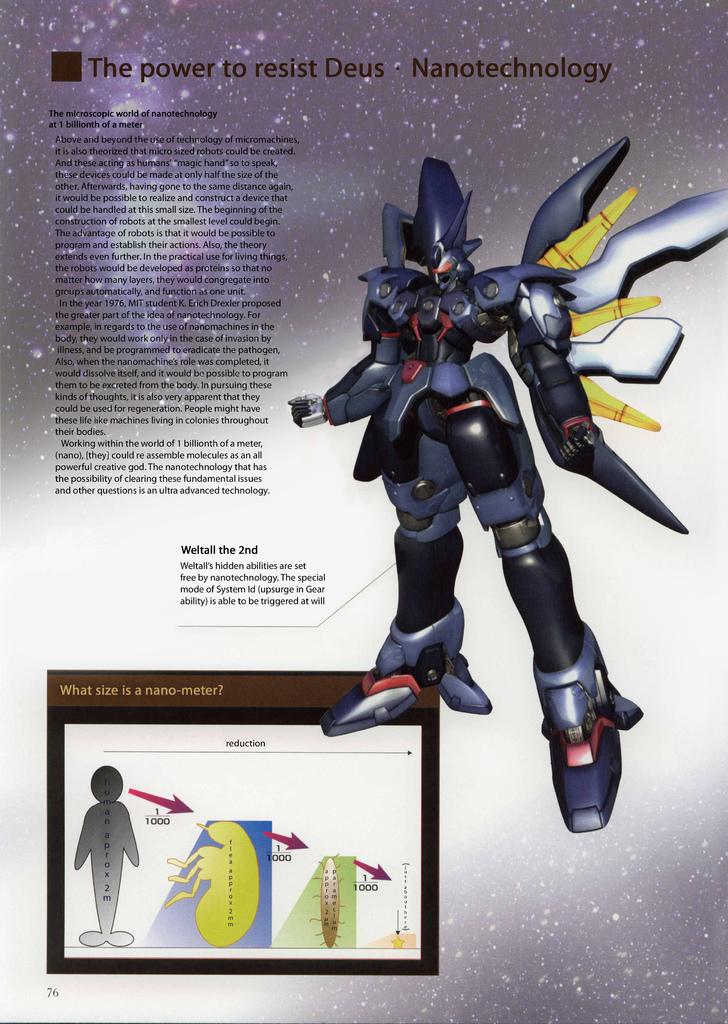The power to resist who?
Give a very brief answer. Deus. The power to what?
Give a very brief answer. Resist deus. 